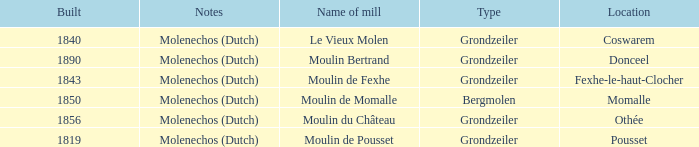What is year Built of the Moulin de Momalle Mill? 1850.0. 